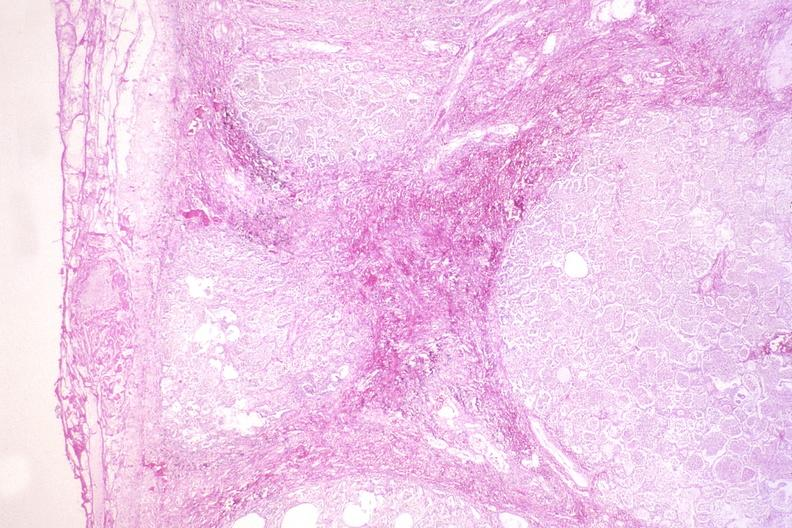where is this?
Answer the question using a single word or phrase. Lung 